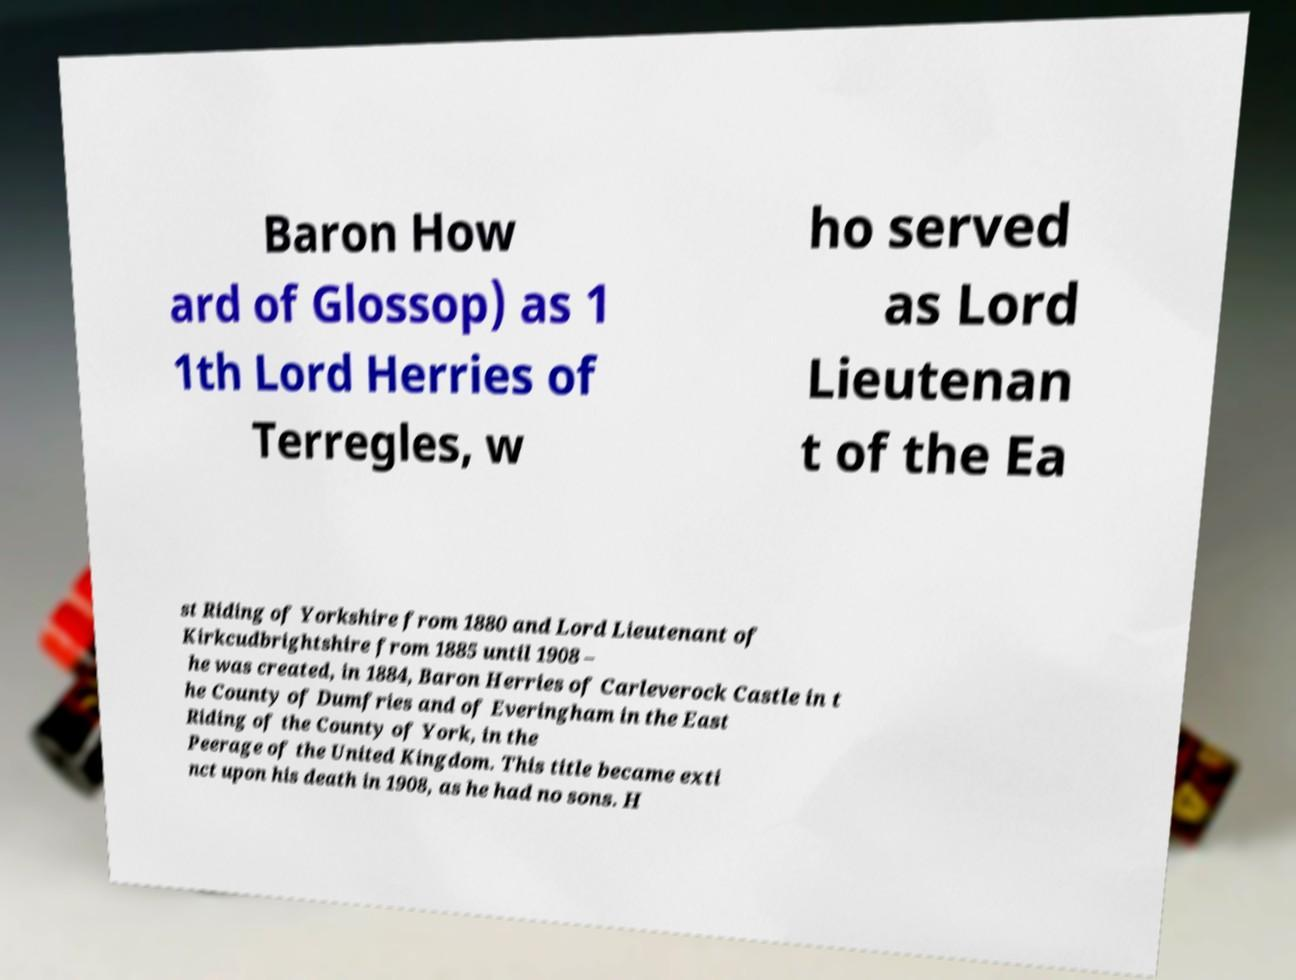For documentation purposes, I need the text within this image transcribed. Could you provide that? Baron How ard of Glossop) as 1 1th Lord Herries of Terregles, w ho served as Lord Lieutenan t of the Ea st Riding of Yorkshire from 1880 and Lord Lieutenant of Kirkcudbrightshire from 1885 until 1908 – he was created, in 1884, Baron Herries of Carleverock Castle in t he County of Dumfries and of Everingham in the East Riding of the County of York, in the Peerage of the United Kingdom. This title became exti nct upon his death in 1908, as he had no sons. H 